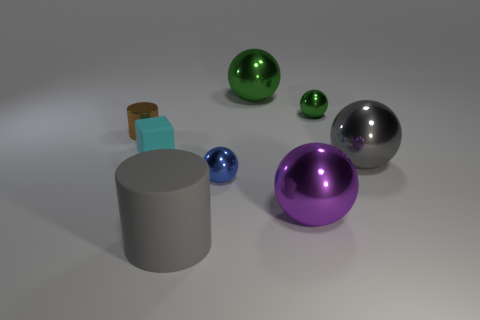Subtract all purple balls. How many balls are left? 4 Subtract all tiny blue shiny spheres. How many spheres are left? 4 Add 2 tiny green things. How many objects exist? 10 Subtract all gray balls. Subtract all green cubes. How many balls are left? 4 Subtract all cylinders. How many objects are left? 6 Add 4 big gray matte objects. How many big gray matte objects exist? 5 Subtract 1 blue balls. How many objects are left? 7 Subtract all large purple matte cubes. Subtract all big matte things. How many objects are left? 7 Add 6 small blue metal balls. How many small blue metal balls are left? 7 